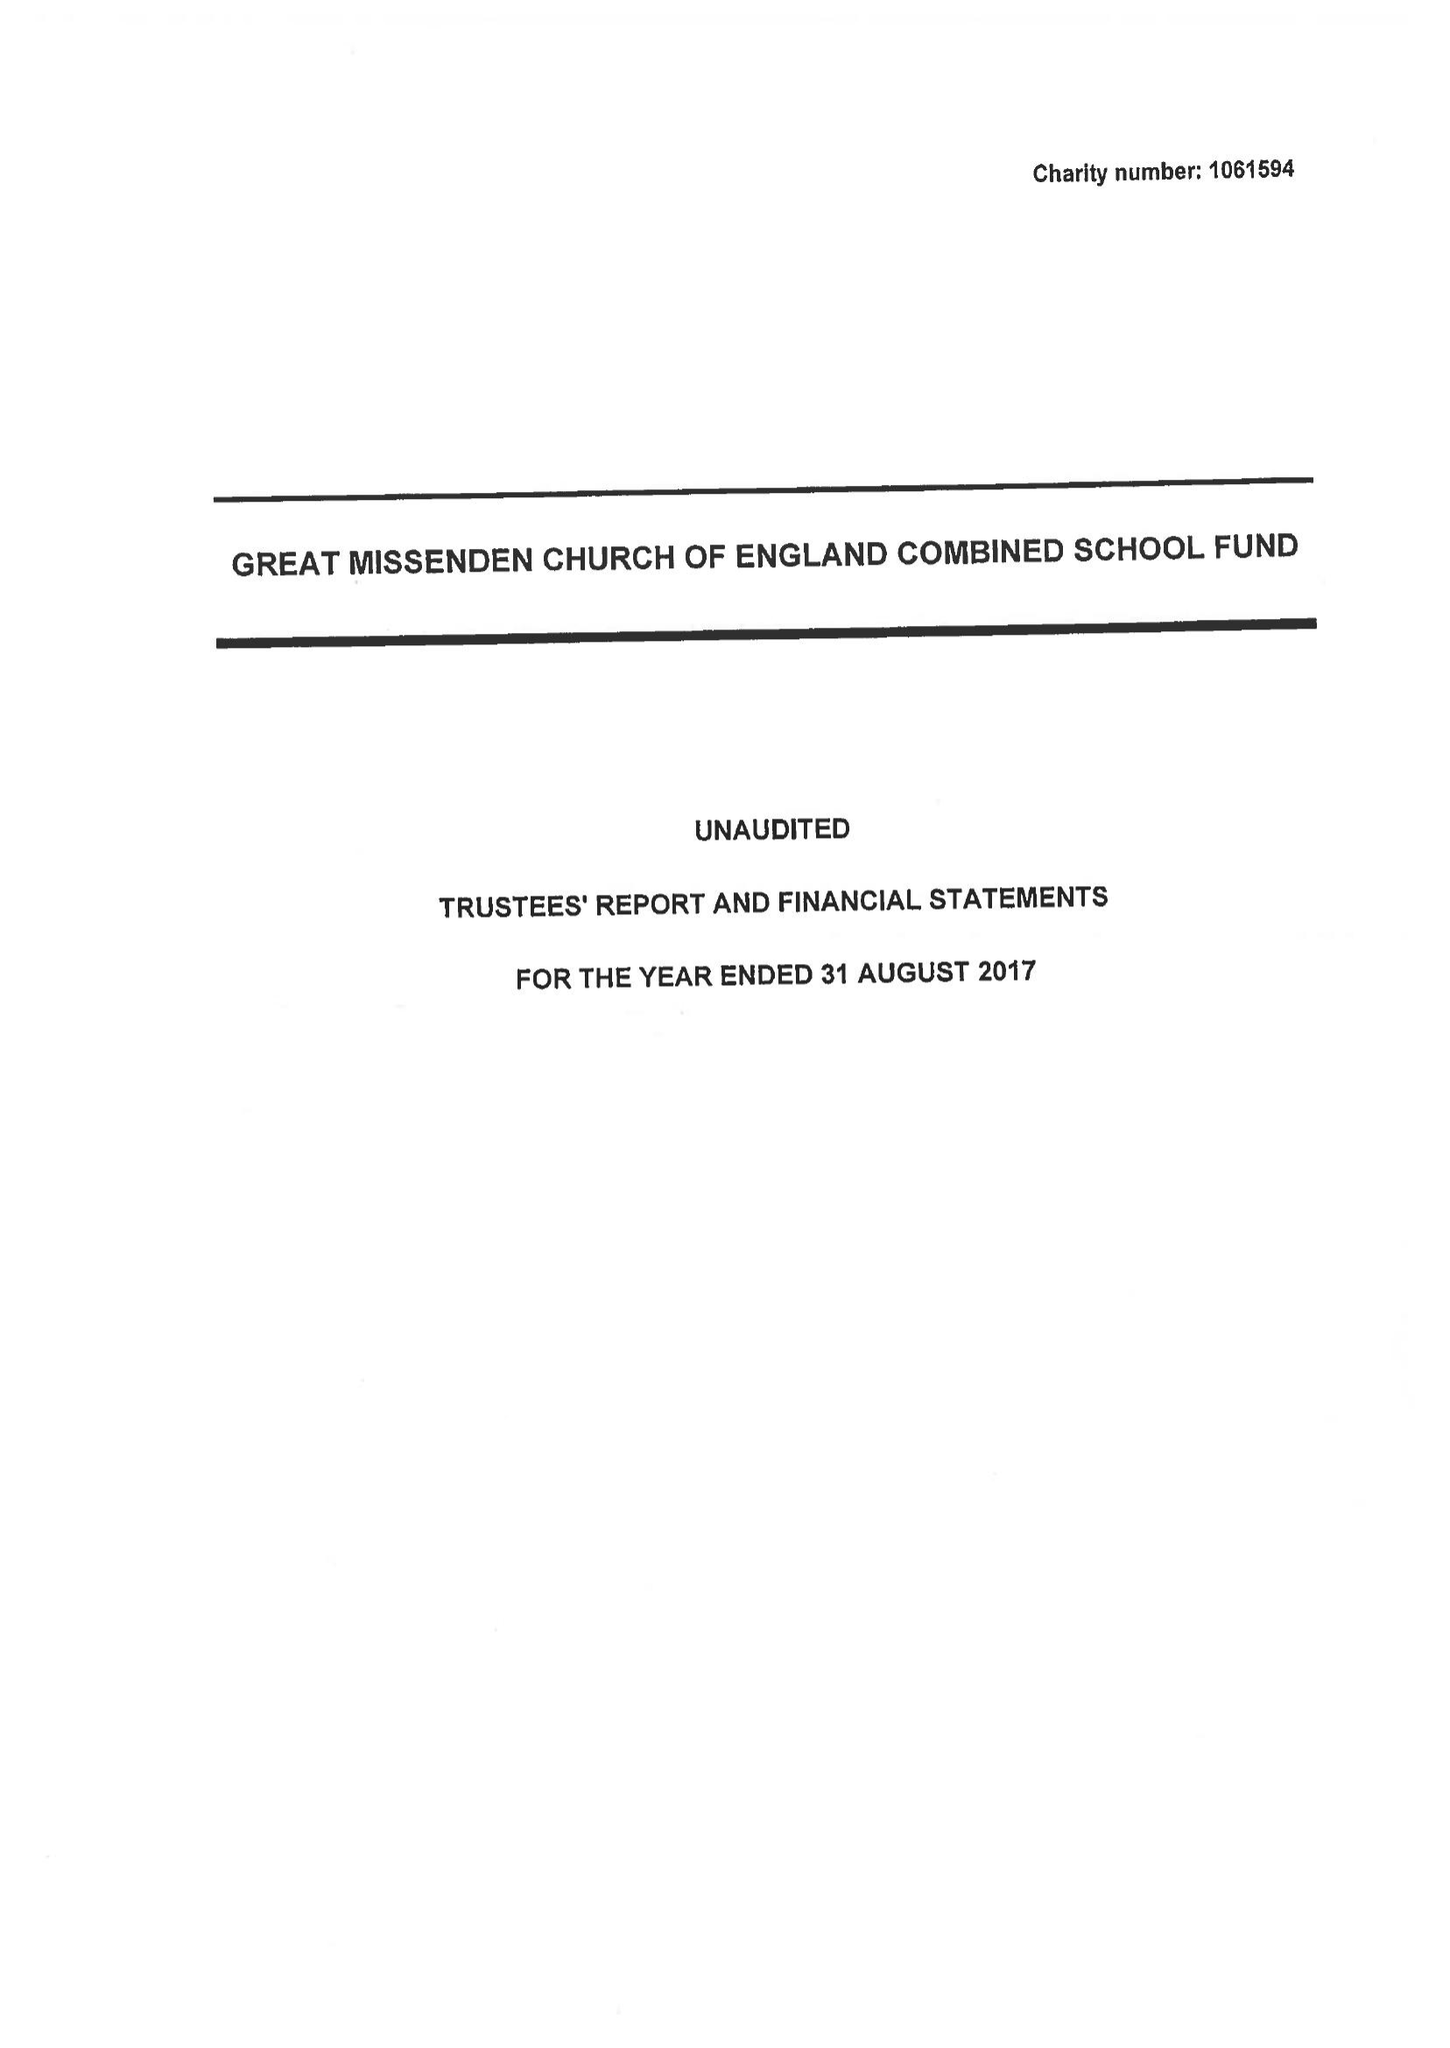What is the value for the income_annually_in_british_pounds?
Answer the question using a single word or phrase. 128089.00 